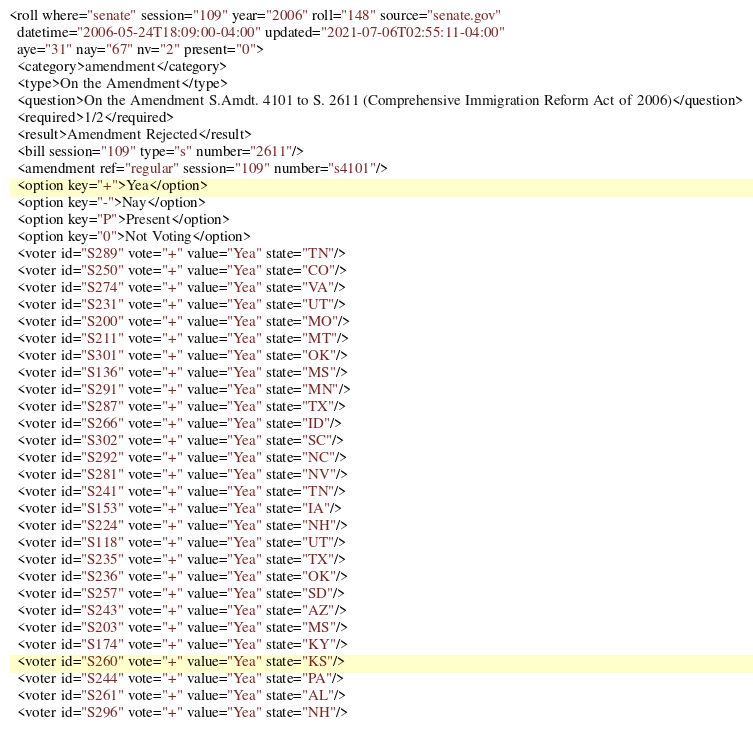<code> <loc_0><loc_0><loc_500><loc_500><_XML_><roll where="senate" session="109" year="2006" roll="148" source="senate.gov"
  datetime="2006-05-24T18:09:00-04:00" updated="2021-07-06T02:55:11-04:00"
  aye="31" nay="67" nv="2" present="0">
  <category>amendment</category>
  <type>On the Amendment</type>
  <question>On the Amendment S.Amdt. 4101 to S. 2611 (Comprehensive Immigration Reform Act of 2006)</question>
  <required>1/2</required>
  <result>Amendment Rejected</result>
  <bill session="109" type="s" number="2611"/>
  <amendment ref="regular" session="109" number="s4101"/>
  <option key="+">Yea</option>
  <option key="-">Nay</option>
  <option key="P">Present</option>
  <option key="0">Not Voting</option>
  <voter id="S289" vote="+" value="Yea" state="TN"/>
  <voter id="S250" vote="+" value="Yea" state="CO"/>
  <voter id="S274" vote="+" value="Yea" state="VA"/>
  <voter id="S231" vote="+" value="Yea" state="UT"/>
  <voter id="S200" vote="+" value="Yea" state="MO"/>
  <voter id="S211" vote="+" value="Yea" state="MT"/>
  <voter id="S301" vote="+" value="Yea" state="OK"/>
  <voter id="S136" vote="+" value="Yea" state="MS"/>
  <voter id="S291" vote="+" value="Yea" state="MN"/>
  <voter id="S287" vote="+" value="Yea" state="TX"/>
  <voter id="S266" vote="+" value="Yea" state="ID"/>
  <voter id="S302" vote="+" value="Yea" state="SC"/>
  <voter id="S292" vote="+" value="Yea" state="NC"/>
  <voter id="S281" vote="+" value="Yea" state="NV"/>
  <voter id="S241" vote="+" value="Yea" state="TN"/>
  <voter id="S153" vote="+" value="Yea" state="IA"/>
  <voter id="S224" vote="+" value="Yea" state="NH"/>
  <voter id="S118" vote="+" value="Yea" state="UT"/>
  <voter id="S235" vote="+" value="Yea" state="TX"/>
  <voter id="S236" vote="+" value="Yea" state="OK"/>
  <voter id="S257" vote="+" value="Yea" state="SD"/>
  <voter id="S243" vote="+" value="Yea" state="AZ"/>
  <voter id="S203" vote="+" value="Yea" state="MS"/>
  <voter id="S174" vote="+" value="Yea" state="KY"/>
  <voter id="S260" vote="+" value="Yea" state="KS"/>
  <voter id="S244" vote="+" value="Yea" state="PA"/>
  <voter id="S261" vote="+" value="Yea" state="AL"/>
  <voter id="S296" vote="+" value="Yea" state="NH"/></code> 